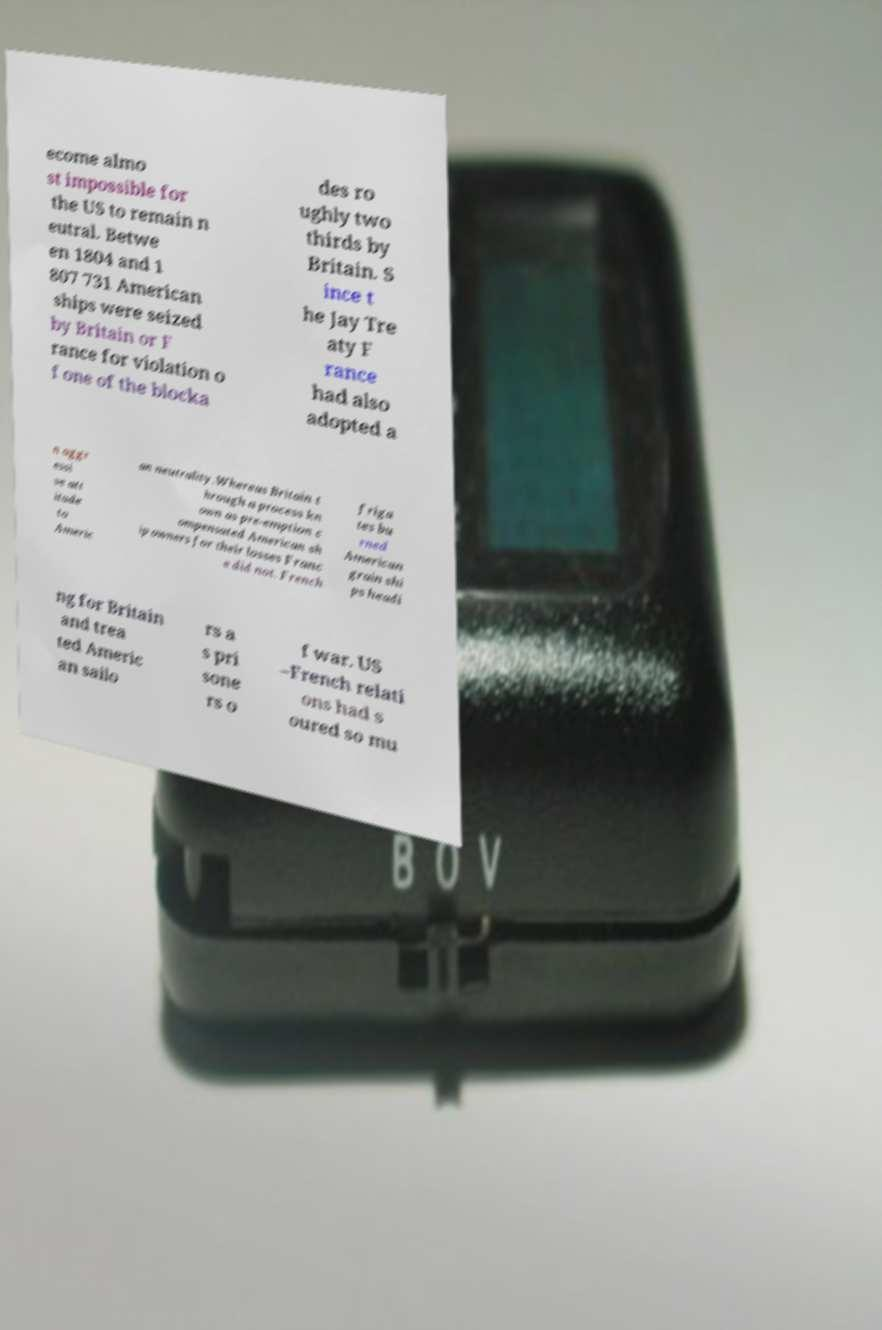What messages or text are displayed in this image? I need them in a readable, typed format. ecome almo st impossible for the US to remain n eutral. Betwe en 1804 and 1 807 731 American ships were seized by Britain or F rance for violation o f one of the blocka des ro ughly two thirds by Britain. S ince t he Jay Tre aty F rance had also adopted a n aggr essi ve att itude to Americ an neutrality.Whereas Britain t hrough a process kn own as pre-emption c ompensated American sh ip owners for their losses Franc e did not. French friga tes bu rned American grain shi ps headi ng for Britain and trea ted Americ an sailo rs a s pri sone rs o f war. US –French relati ons had s oured so mu 